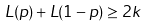Convert formula to latex. <formula><loc_0><loc_0><loc_500><loc_500>L ( p ) + L ( 1 - p ) \geq 2 k</formula> 